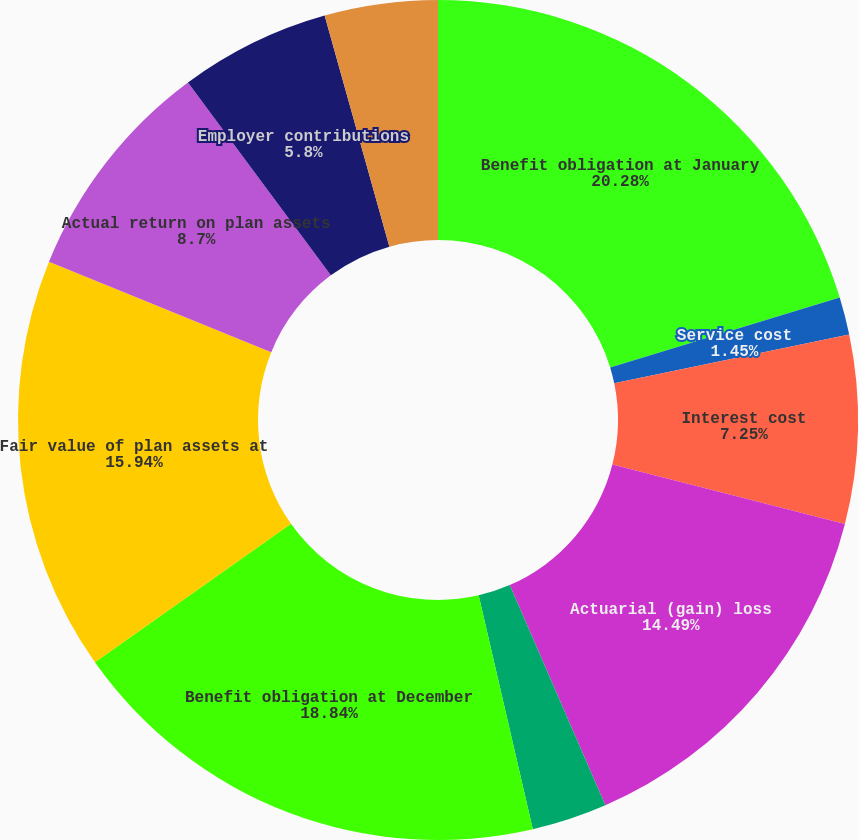Convert chart. <chart><loc_0><loc_0><loc_500><loc_500><pie_chart><fcel>Benefit obligation at January<fcel>Service cost<fcel>Interest cost<fcel>Actuarial (gain) loss<fcel>Gross benefits paid<fcel>Benefit obligation at December<fcel>Fair value of plan assets at<fcel>Actual return on plan assets<fcel>Employer contributions<fcel>Benefits paid<nl><fcel>20.29%<fcel>1.45%<fcel>7.25%<fcel>14.49%<fcel>2.9%<fcel>18.84%<fcel>15.94%<fcel>8.7%<fcel>5.8%<fcel>4.35%<nl></chart> 